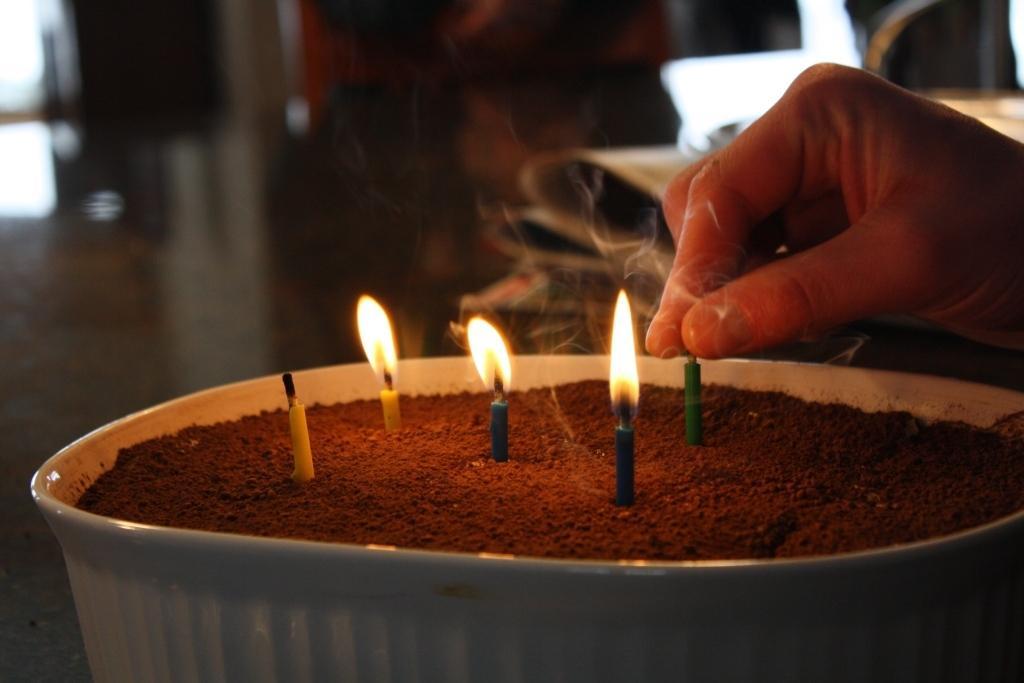Could you give a brief overview of what you see in this image? In this image we can see candles and sand in a bowl. On the right side of the image we can see hand of a person. There is a blur background. 